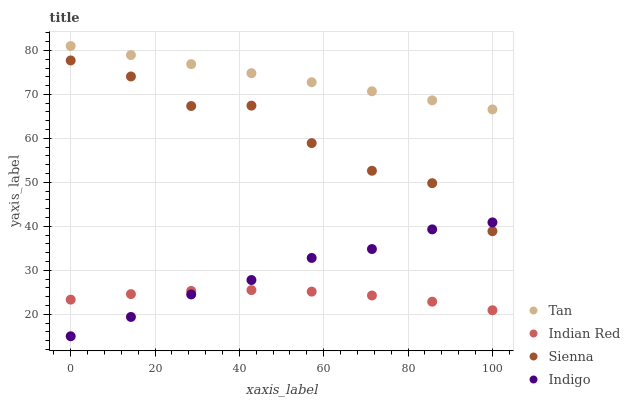Does Indian Red have the minimum area under the curve?
Answer yes or no. Yes. Does Tan have the maximum area under the curve?
Answer yes or no. Yes. Does Indigo have the minimum area under the curve?
Answer yes or no. No. Does Indigo have the maximum area under the curve?
Answer yes or no. No. Is Tan the smoothest?
Answer yes or no. Yes. Is Sienna the roughest?
Answer yes or no. Yes. Is Indigo the smoothest?
Answer yes or no. No. Is Indigo the roughest?
Answer yes or no. No. Does Indigo have the lowest value?
Answer yes or no. Yes. Does Tan have the lowest value?
Answer yes or no. No. Does Tan have the highest value?
Answer yes or no. Yes. Does Indigo have the highest value?
Answer yes or no. No. Is Indian Red less than Tan?
Answer yes or no. Yes. Is Tan greater than Indigo?
Answer yes or no. Yes. Does Indian Red intersect Indigo?
Answer yes or no. Yes. Is Indian Red less than Indigo?
Answer yes or no. No. Is Indian Red greater than Indigo?
Answer yes or no. No. Does Indian Red intersect Tan?
Answer yes or no. No. 